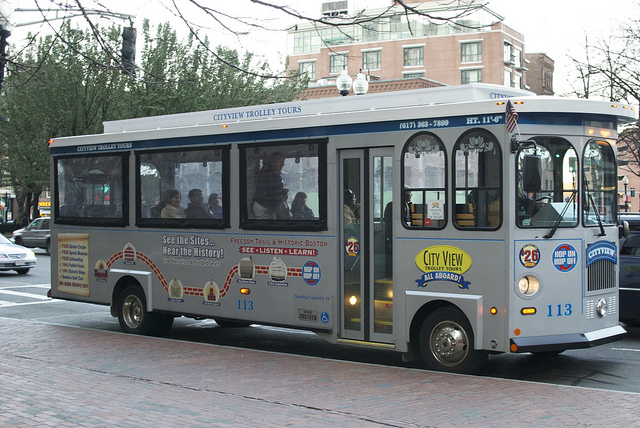Please identify all text content in this image. see the sales Hear the 11'0" HT TOURS T&amp;OLLEY CITYVIEW History 26 HOP 26 113 VIEW CITY 